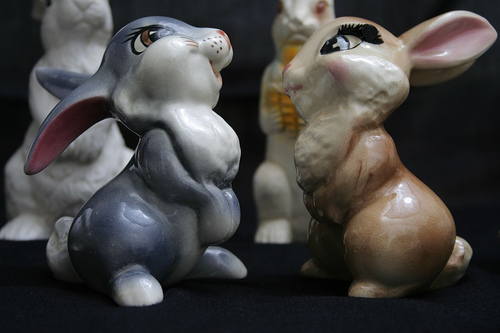<image>
Is the rabbit in front of the rabbit? Yes. The rabbit is positioned in front of the rabbit, appearing closer to the camera viewpoint. 